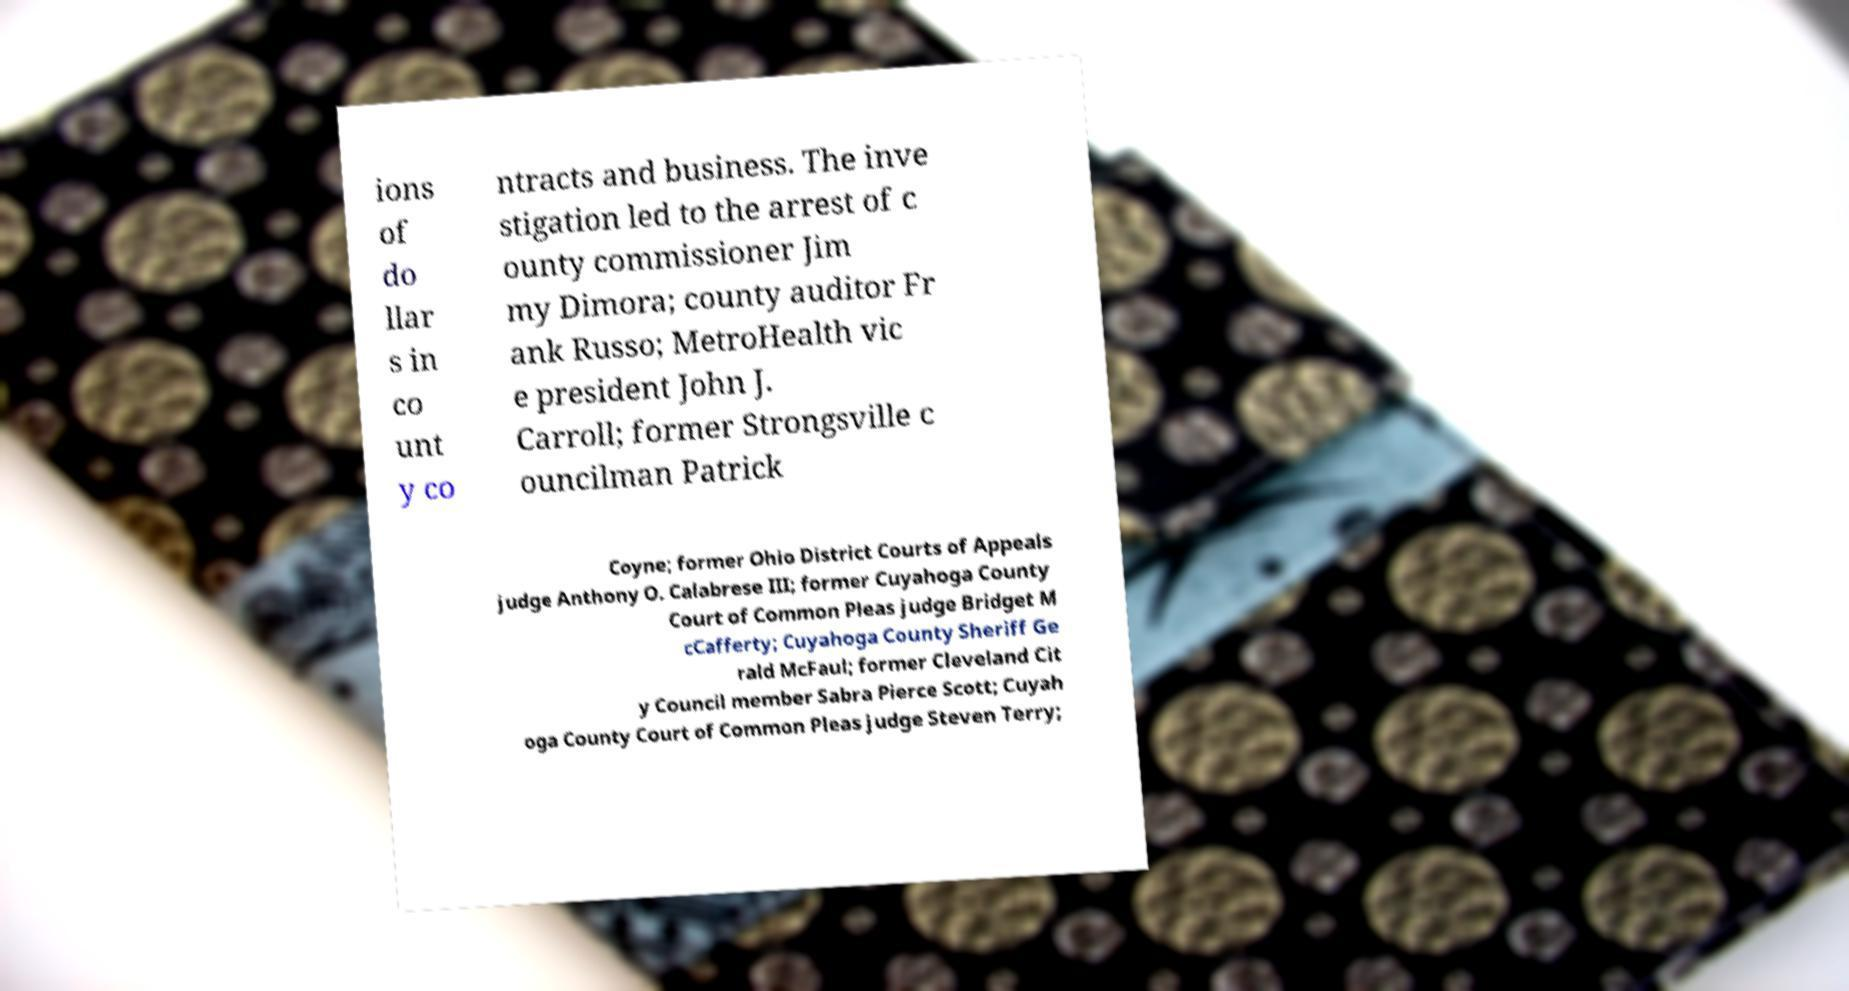Please read and relay the text visible in this image. What does it say? ions of do llar s in co unt y co ntracts and business. The inve stigation led to the arrest of c ounty commissioner Jim my Dimora; county auditor Fr ank Russo; MetroHealth vic e president John J. Carroll; former Strongsville c ouncilman Patrick Coyne; former Ohio District Courts of Appeals judge Anthony O. Calabrese III; former Cuyahoga County Court of Common Pleas judge Bridget M cCafferty; Cuyahoga County Sheriff Ge rald McFaul; former Cleveland Cit y Council member Sabra Pierce Scott; Cuyah oga County Court of Common Pleas judge Steven Terry; 